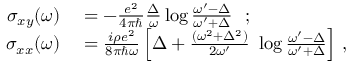Convert formula to latex. <formula><loc_0><loc_0><loc_500><loc_500>\begin{array} { r l } { \sigma _ { x y } ( \omega ) } & = - \frac { e ^ { 2 } } { 4 \pi } \frac { \Delta } { \omega } \log \frac { \omega ^ { \prime } - \Delta } { \omega ^ { \prime } + \Delta } \ \ ; } \\ { \sigma _ { x x } ( \omega ) } & = \frac { i \rho e ^ { 2 } } { 8 \pi \hbar { \omega } } \left [ \Delta + \frac { ( \omega ^ { 2 } + \Delta ^ { 2 } ) } { 2 \omega ^ { \prime } } \ \log \frac { \omega ^ { \prime } - \Delta } { \omega ^ { \prime } + \Delta } \right ] \, , } \end{array}</formula> 